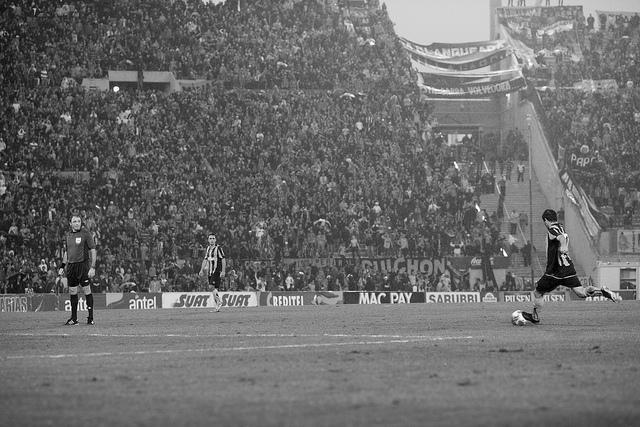How many people are visible?
Give a very brief answer. 3. 